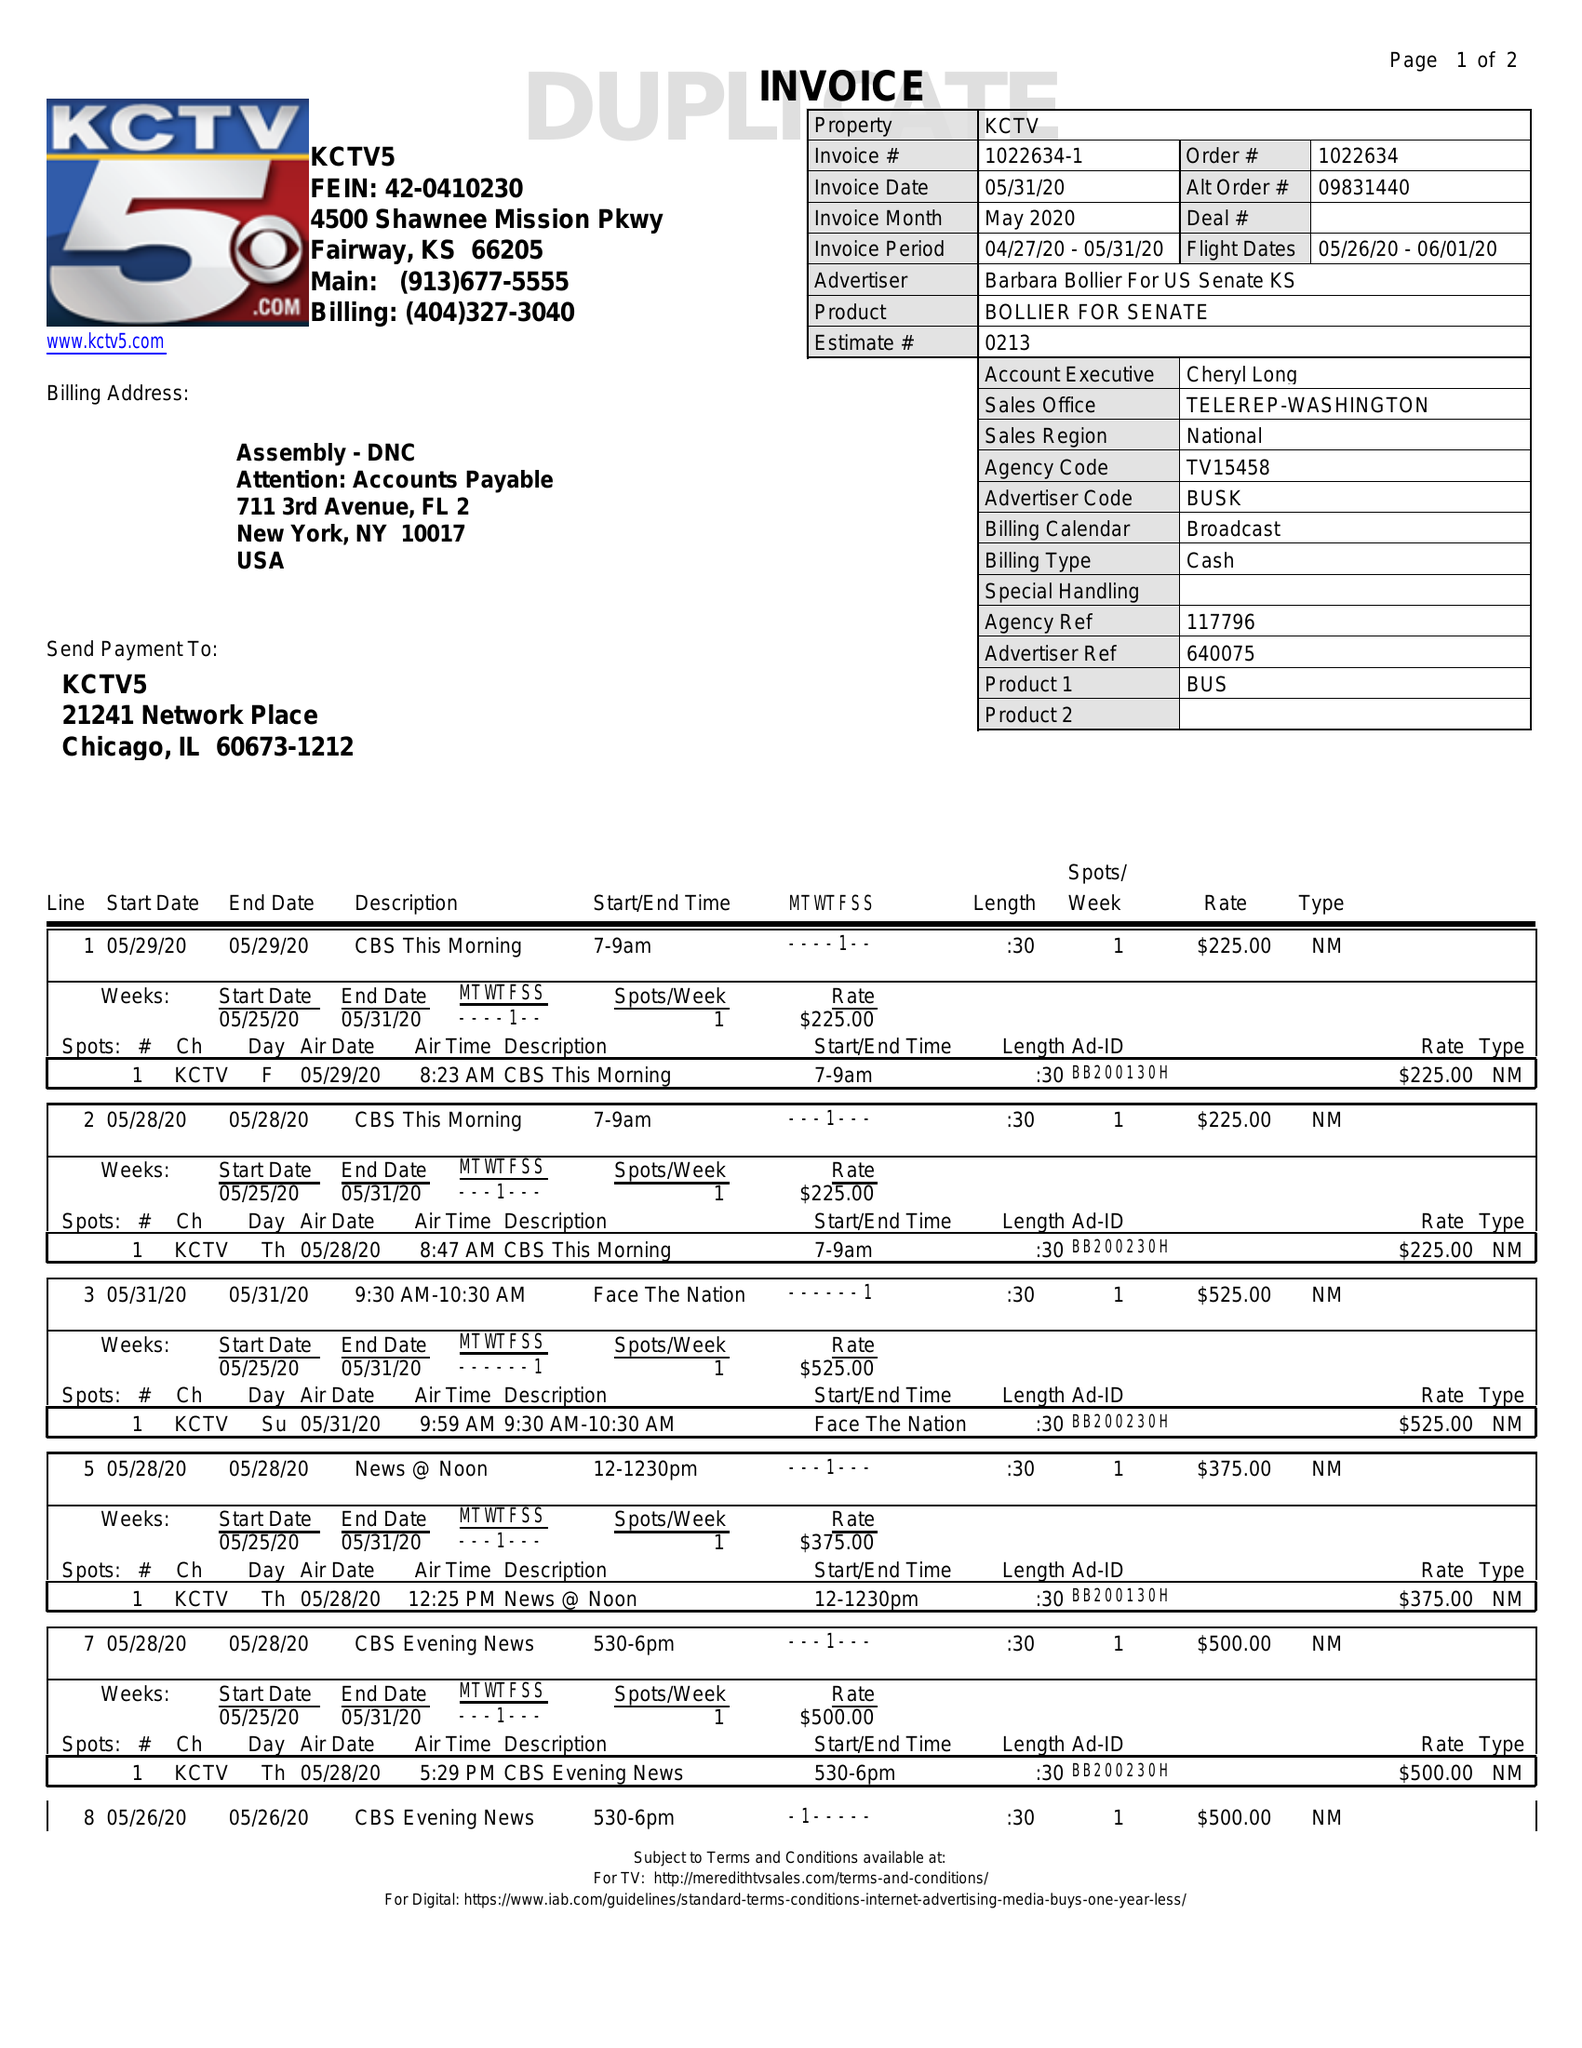What is the value for the contract_num?
Answer the question using a single word or phrase. 1022634 